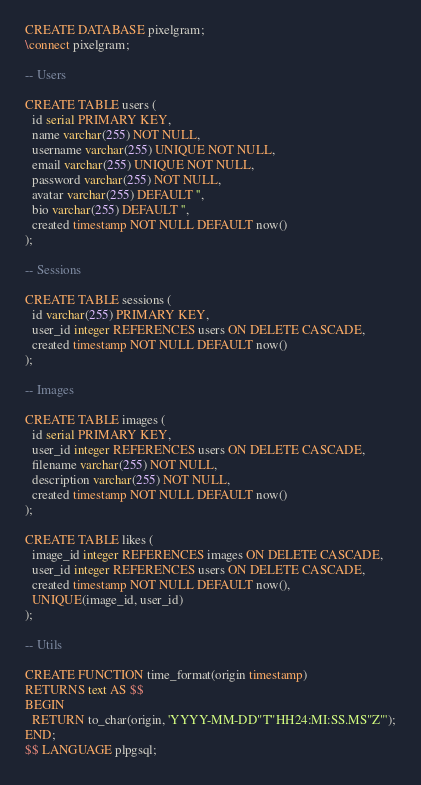<code> <loc_0><loc_0><loc_500><loc_500><_SQL_>CREATE DATABASE pixelgram;
\connect pixelgram;

-- Users

CREATE TABLE users (
  id serial PRIMARY KEY,
  name varchar(255) NOT NULL,
  username varchar(255) UNIQUE NOT NULL,
  email varchar(255) UNIQUE NOT NULL,
  password varchar(255) NOT NULL,
  avatar varchar(255) DEFAULT '',
  bio varchar(255) DEFAULT '',
  created timestamp NOT NULL DEFAULT now()
);

-- Sessions

CREATE TABLE sessions (
  id varchar(255) PRIMARY KEY,
  user_id integer REFERENCES users ON DELETE CASCADE,
  created timestamp NOT NULL DEFAULT now()
);

-- Images

CREATE TABLE images (
  id serial PRIMARY KEY,
  user_id integer REFERENCES users ON DELETE CASCADE,
  filename varchar(255) NOT NULL,
  description varchar(255) NOT NULL,
  created timestamp NOT NULL DEFAULT now()
);

CREATE TABLE likes (
  image_id integer REFERENCES images ON DELETE CASCADE,
  user_id integer REFERENCES users ON DELETE CASCADE,
  created timestamp NOT NULL DEFAULT now(),
  UNIQUE(image_id, user_id)
);

-- Utils

CREATE FUNCTION time_format(origin timestamp)
RETURNS text AS $$
BEGIN
  RETURN to_char(origin, 'YYYY-MM-DD"T"HH24:MI:SS.MS"Z"');
END;
$$ LANGUAGE plpgsql;
</code> 